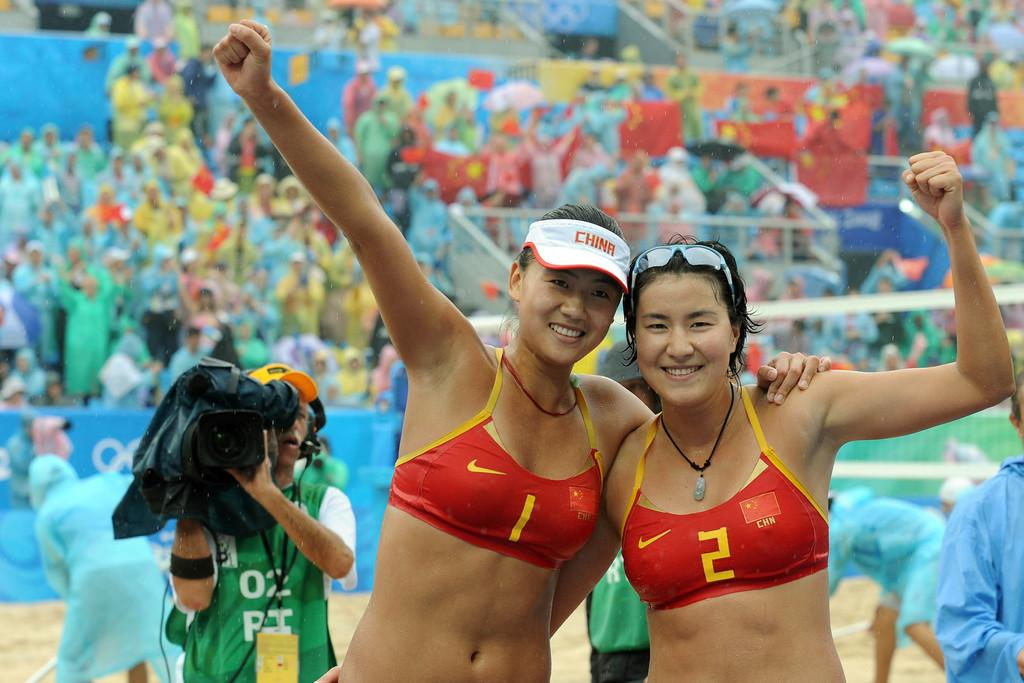Provide a one-sentence caption for the provided image. The victorious team celebrates another professional volleyball victory. 